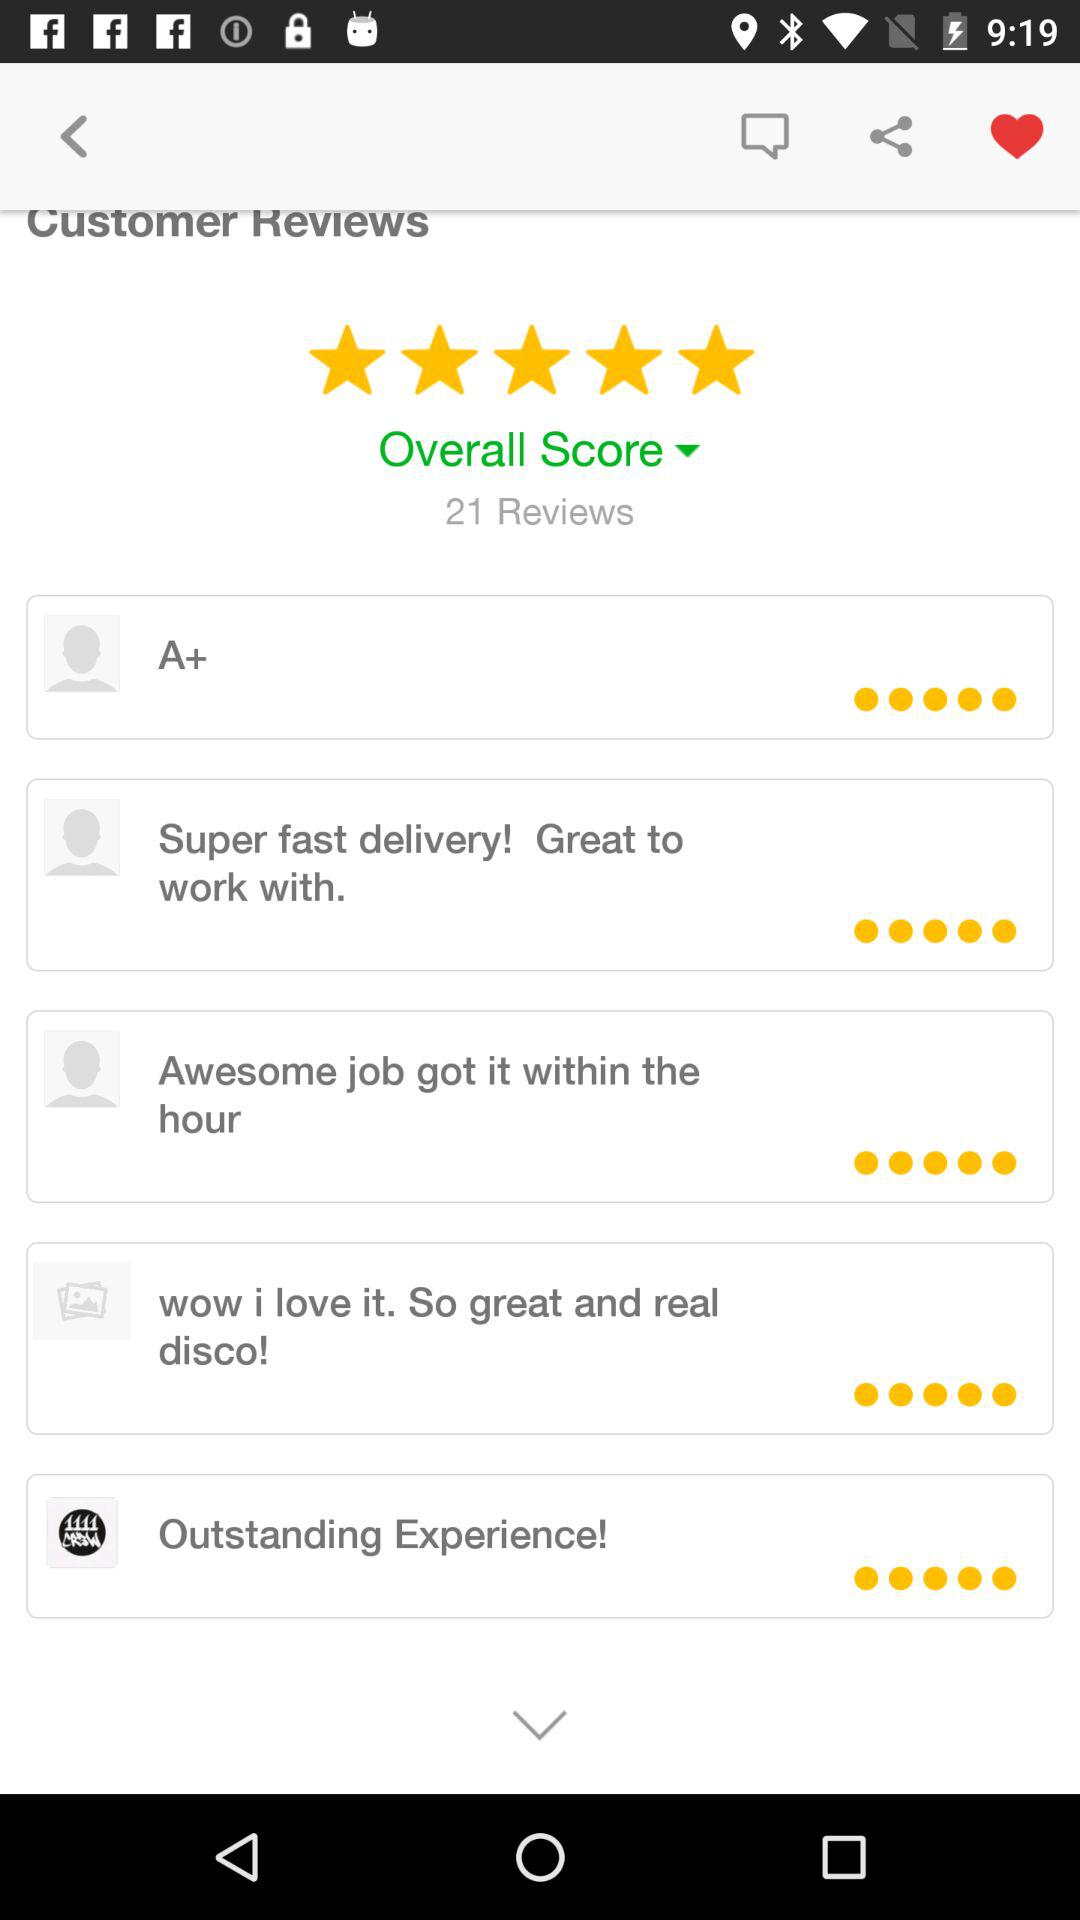What is the overall rating? The overall rating is 5 stars. 